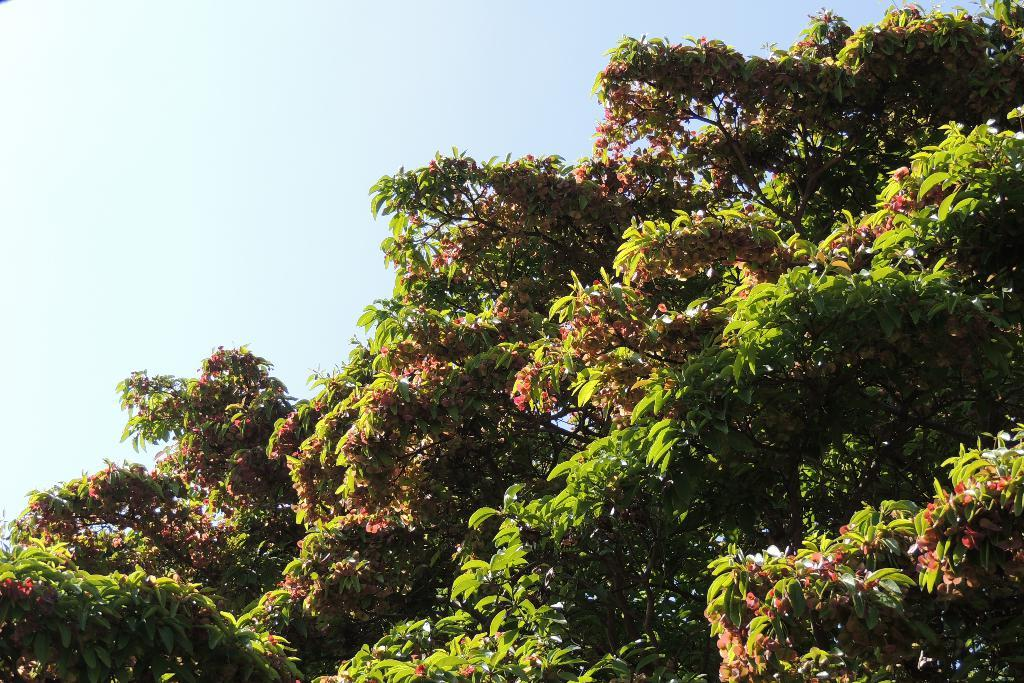What type of plant is visible in the image? There is a branch with leaves in the image. What part of the natural environment is visible in the image? The sky is visible at the top of the image. What type of songs can be heard coming from the sink in the image? There is no sink present in the image, and therefore no songs can be heard from it. 